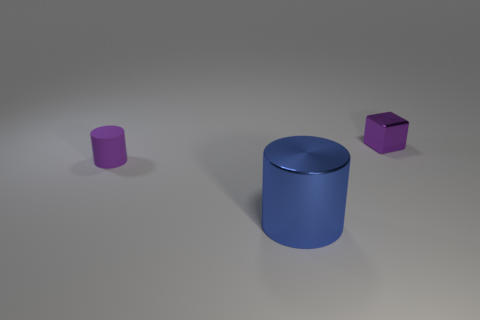Add 1 purple matte things. How many objects exist? 4 Subtract all blocks. How many objects are left? 2 Add 2 big blue things. How many big blue things are left? 3 Add 1 large blue things. How many large blue things exist? 2 Subtract 1 purple blocks. How many objects are left? 2 Subtract all metal blocks. Subtract all cylinders. How many objects are left? 0 